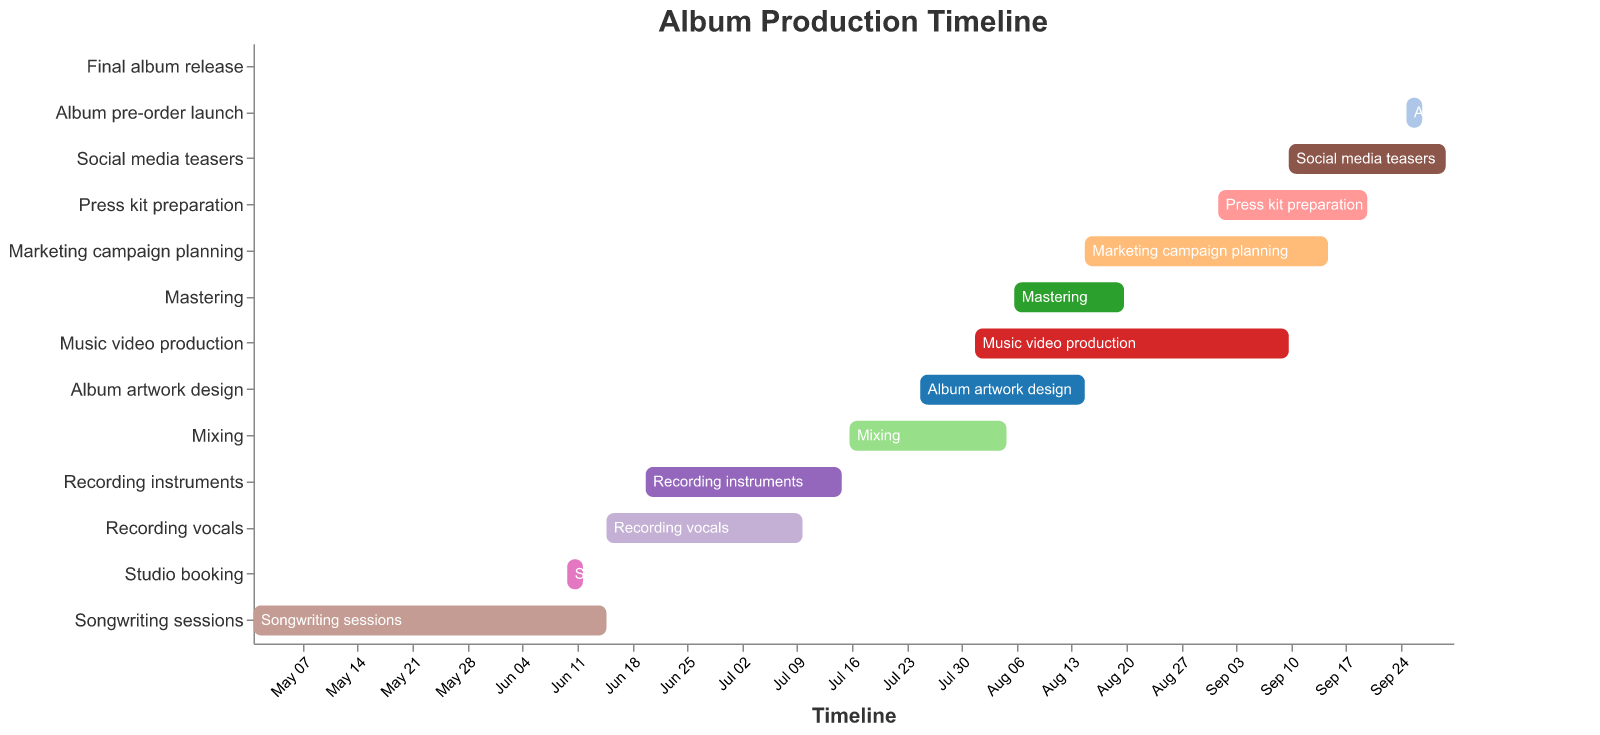What is the earliest task in the album production timeline, and when does it start? The earliest task in the Gantt Chart is the one with the earliest "Start" date. From the data, "Songwriting sessions" start on 2023-05-01, which is the earliest date.
Answer: Songwriting sessions start on May 1, 2023 Which tasks overlap with "Recording vocals"? To find overlaps, we need to check which tasks have a date range that falls within the "Recording vocals" period, which is June 15, 2023, to July 10, 2023. "Studio booking" (June 10 to June 12), "Recording instruments" (June 20 to July 15), and "Songwriting sessions" (until June 15) overlap partially or fully with "Recording vocals".
Answer: Studio booking, Recording instruments, Songwriting sessions What is the total duration of the "Music video production"? The duration is calculated by the difference between the "Start" and "End" dates of the task. "Music video production" starts on 2023-08-01 and ends on 2023-09-10. The total duration is the number of days between these dates. Using a date calculator or manually, the total duration is 41 days.
Answer: 41 days Which task is directly before "Mixing" in the timeline? By examining the end dates of different tasks, the task that finishes closest to and before the start date of "Mixing" (2023-07-16) is "Recording instruments" which ends on 2023-07-15.
Answer: Recording instruments What is the time gap between the "Songwriting sessions" and "Final album release"? The "Songwriting sessions" end on 2023-06-15 and the "Final album release" is on 2023-10-01. Calculate the time gap between these dates to determine the total days or months. The difference in months is roughly 3 months and 16 days.
Answer: About 3 months and 16 days How many days are spent on "Album artwork design"? "Album artwork design" starts on 2023-07-25 and ends on 2023-08-15. To calculate the duration, count the number of days in the date range. The task spans from July 25 to August 15, which is a total of 22 days.
Answer: 22 days Which tasks continue into September 2023? Tasks that have an "End" date in or after September 2023 are considered here. These tasks are "Music video production" (ends on September 10), "Marketing campaign planning" (ends on September 15), "Press kit preparation" (ends on September 20), "Social media teasers" (ends on September 30), and "Album pre-order launch" (ends on September 27).
Answer: Music video production, Marketing campaign planning, Press kit preparation, Social media teasers, Album pre-order launch 